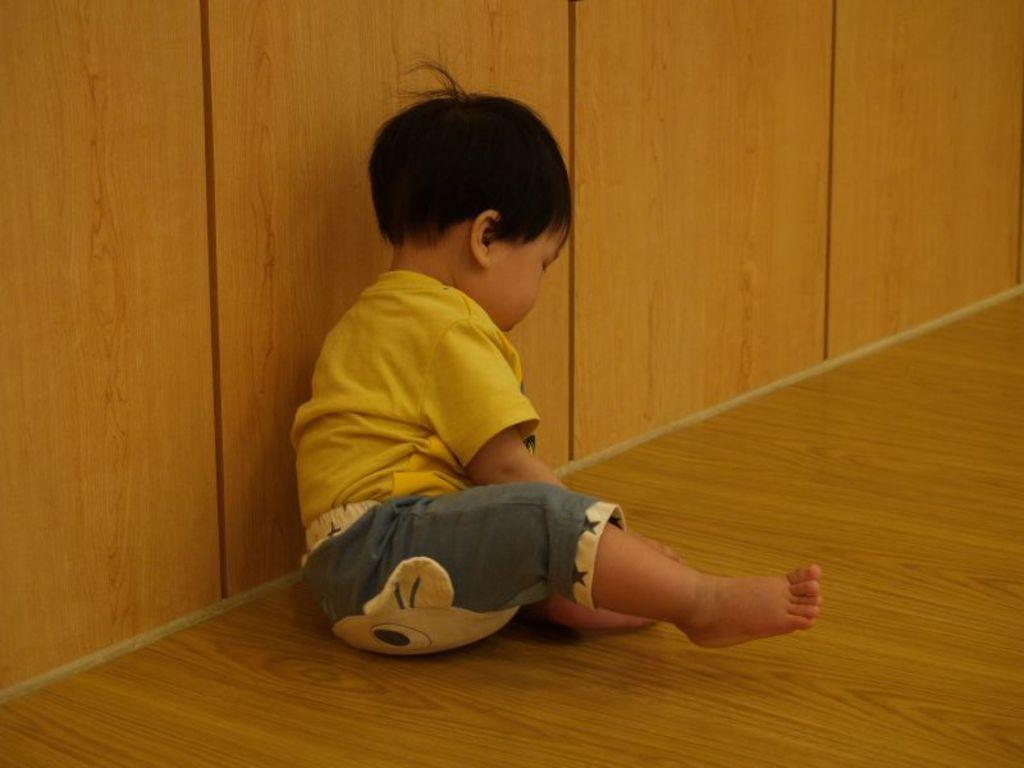Who is the main subject in the image? There is a boy in the image. What is the boy doing in the image? The boy is sitting on the floor. Where is the boy located in the image? The boy is in the middle of the image. What type of wall can be seen in the image? There is a wooden wall in the image. What type of locket is the boy holding in the image? There is no locket present in the image; the boy is sitting on the floor without any visible objects in his hands. 